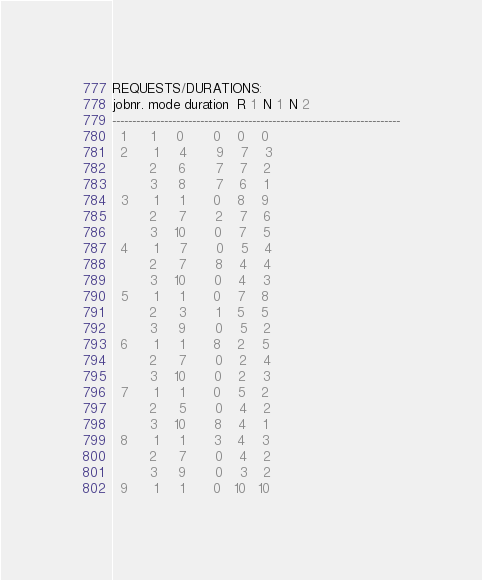<code> <loc_0><loc_0><loc_500><loc_500><_ObjectiveC_>REQUESTS/DURATIONS:
jobnr. mode duration  R 1  N 1  N 2
------------------------------------------------------------------------
  1      1     0       0    0    0
  2      1     4       9    7    3
         2     6       7    7    2
         3     8       7    6    1
  3      1     1       0    8    9
         2     7       2    7    6
         3    10       0    7    5
  4      1     7       0    5    4
         2     7       8    4    4
         3    10       0    4    3
  5      1     1       0    7    8
         2     3       1    5    5
         3     9       0    5    2
  6      1     1       8    2    5
         2     7       0    2    4
         3    10       0    2    3
  7      1     1       0    5    2
         2     5       0    4    2
         3    10       8    4    1
  8      1     1       3    4    3
         2     7       0    4    2
         3     9       0    3    2
  9      1     1       0   10   10</code> 